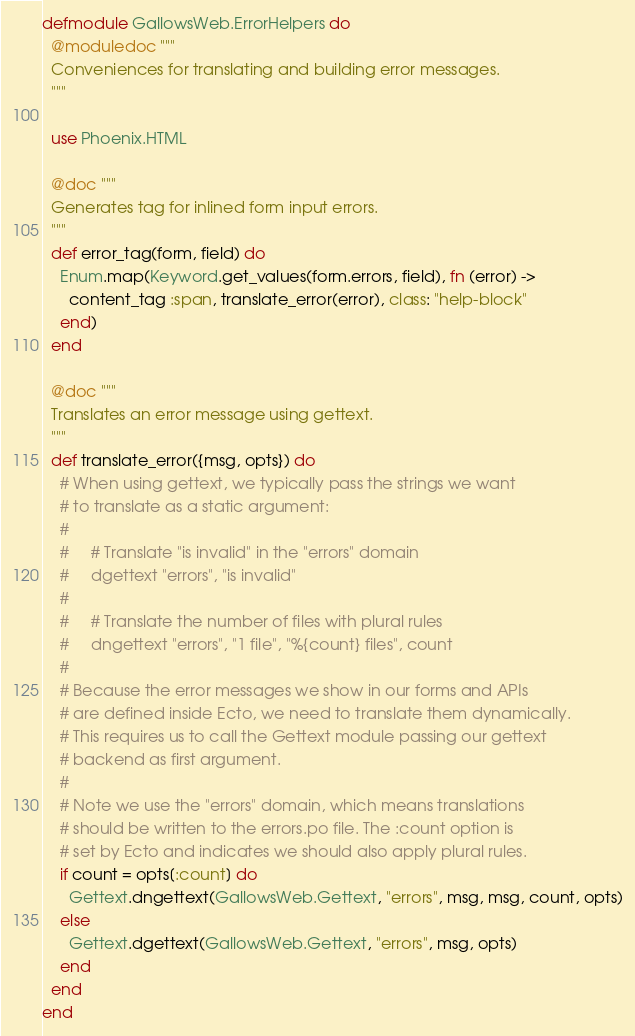Convert code to text. <code><loc_0><loc_0><loc_500><loc_500><_Elixir_>defmodule GallowsWeb.ErrorHelpers do
  @moduledoc """
  Conveniences for translating and building error messages.
  """

  use Phoenix.HTML

  @doc """
  Generates tag for inlined form input errors.
  """
  def error_tag(form, field) do
    Enum.map(Keyword.get_values(form.errors, field), fn (error) ->
      content_tag :span, translate_error(error), class: "help-block"
    end)
  end

  @doc """
  Translates an error message using gettext.
  """
  def translate_error({msg, opts}) do
    # When using gettext, we typically pass the strings we want
    # to translate as a static argument:
    #
    #     # Translate "is invalid" in the "errors" domain
    #     dgettext "errors", "is invalid"
    #
    #     # Translate the number of files with plural rules
    #     dngettext "errors", "1 file", "%{count} files", count
    #
    # Because the error messages we show in our forms and APIs
    # are defined inside Ecto, we need to translate them dynamically.
    # This requires us to call the Gettext module passing our gettext
    # backend as first argument.
    #
    # Note we use the "errors" domain, which means translations
    # should be written to the errors.po file. The :count option is
    # set by Ecto and indicates we should also apply plural rules.
    if count = opts[:count] do
      Gettext.dngettext(GallowsWeb.Gettext, "errors", msg, msg, count, opts)
    else
      Gettext.dgettext(GallowsWeb.Gettext, "errors", msg, opts)
    end
  end
end
</code> 